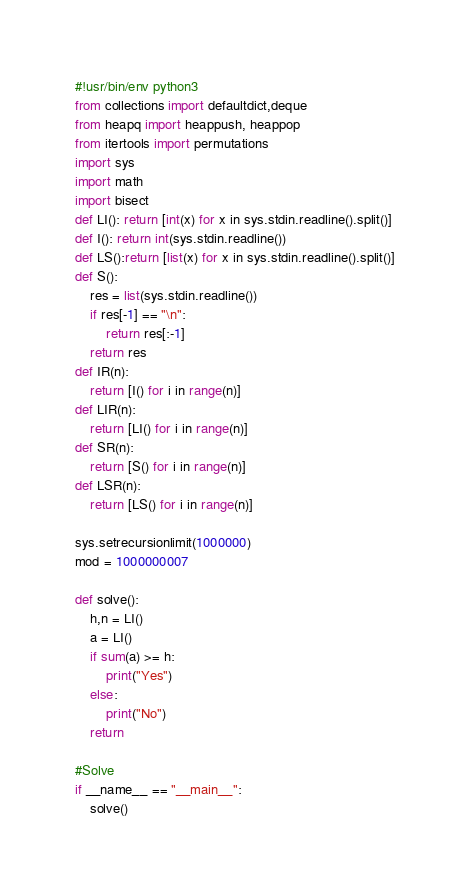<code> <loc_0><loc_0><loc_500><loc_500><_Python_>#!usr/bin/env python3
from collections import defaultdict,deque
from heapq import heappush, heappop
from itertools import permutations
import sys
import math
import bisect
def LI(): return [int(x) for x in sys.stdin.readline().split()]
def I(): return int(sys.stdin.readline())
def LS():return [list(x) for x in sys.stdin.readline().split()]
def S():
    res = list(sys.stdin.readline())
    if res[-1] == "\n":
        return res[:-1]
    return res
def IR(n):
    return [I() for i in range(n)]
def LIR(n):
    return [LI() for i in range(n)]
def SR(n):
    return [S() for i in range(n)]
def LSR(n):
    return [LS() for i in range(n)]

sys.setrecursionlimit(1000000)
mod = 1000000007

def solve():
    h,n = LI()
    a = LI()
    if sum(a) >= h:
        print("Yes")
    else:
        print("No")
    return

#Solve
if __name__ == "__main__":
    solve()
</code> 